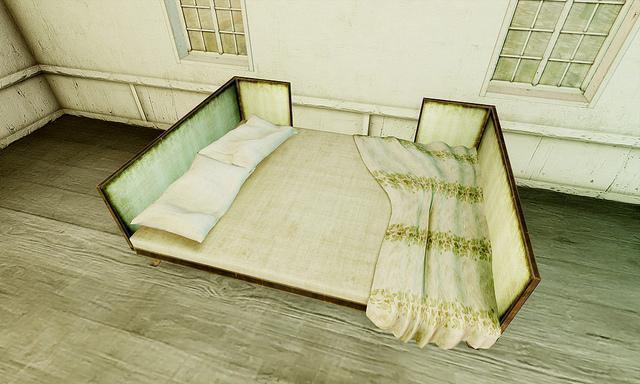How many pillows are on the bed?
Give a very brief answer. 2. How many windows are visible?
Give a very brief answer. 2. 